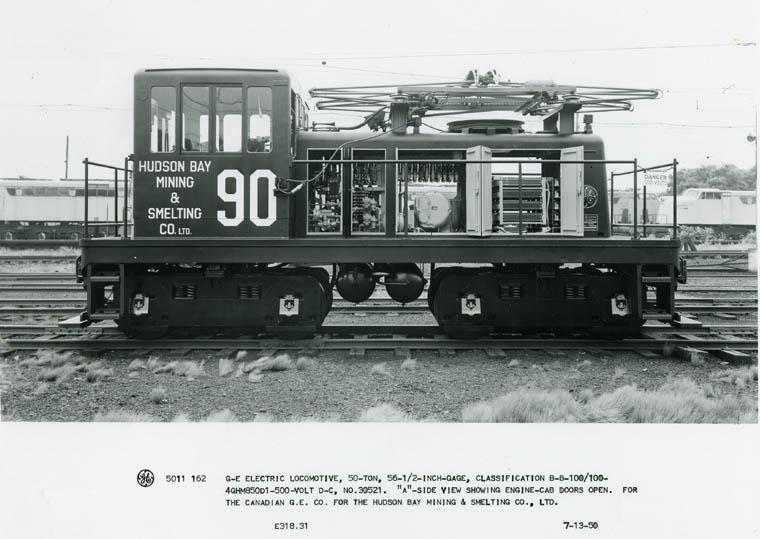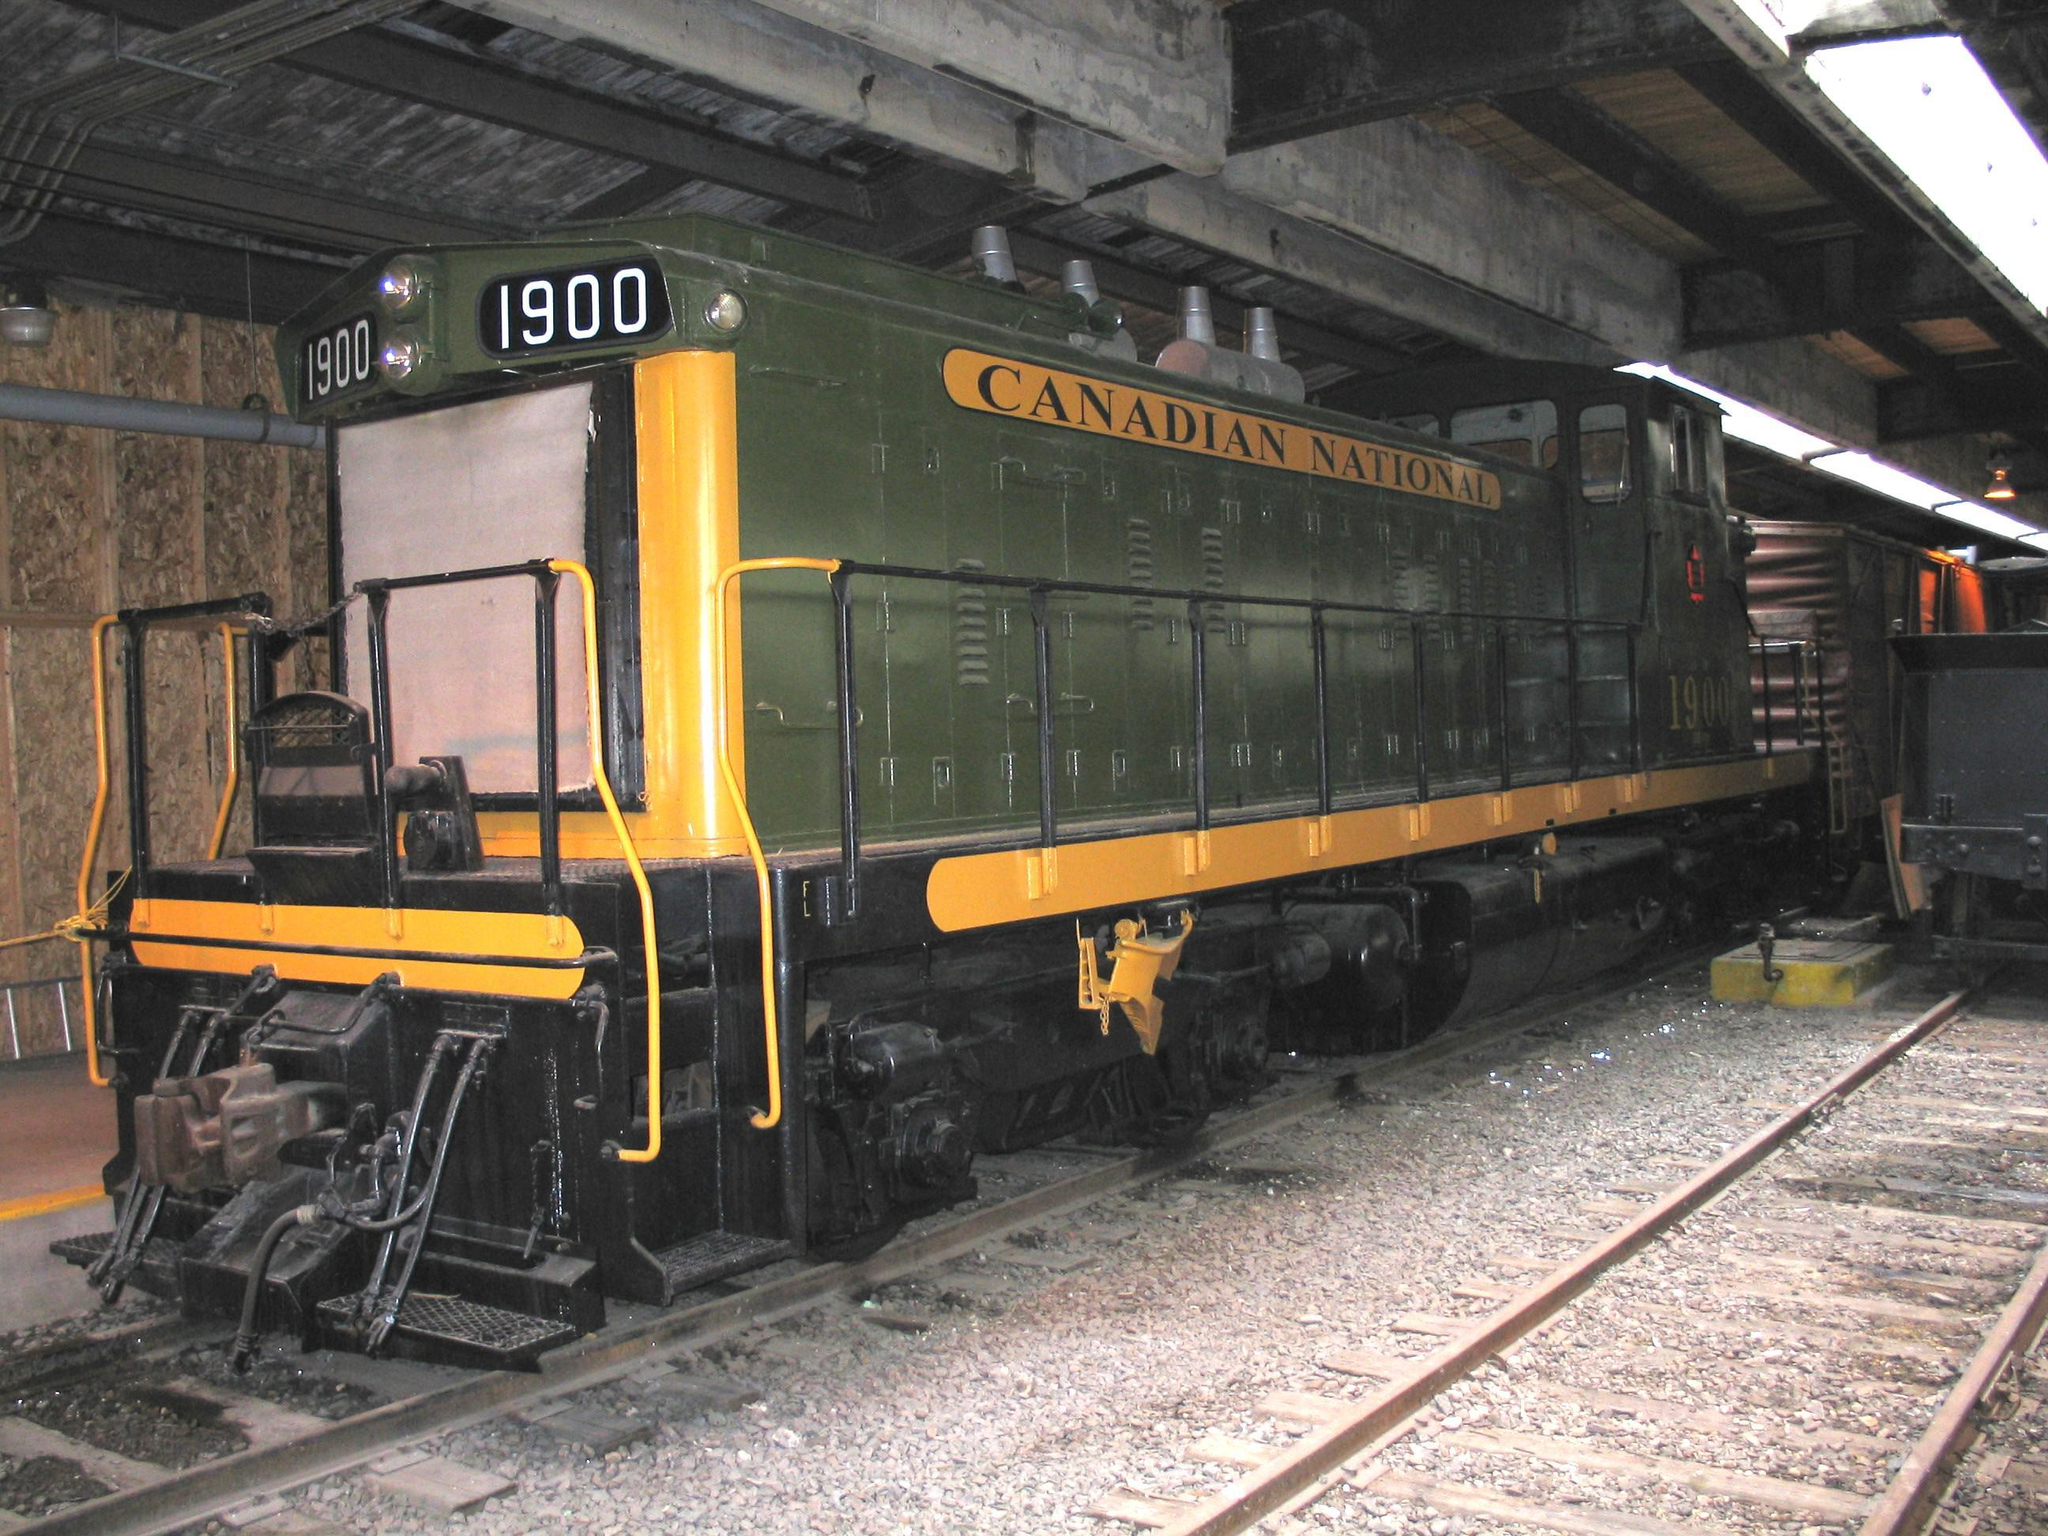The first image is the image on the left, the second image is the image on the right. For the images displayed, is the sentence "A train with three windows across the front is angled so it points right." factually correct? Answer yes or no. No. The first image is the image on the left, the second image is the image on the right. Examine the images to the left and right. Is the description "There is a blue train facing right." accurate? Answer yes or no. No. 